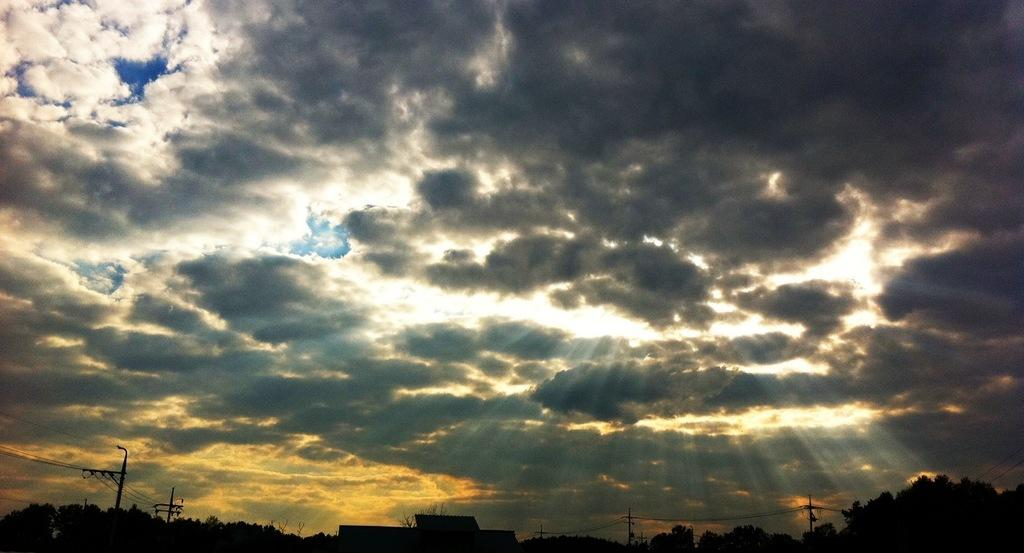What is connecting the poles in the image? Wires are connecting the poles in the image. What can be seen at the bottom of the image? There are trees and buildings at the bottom of the image. What is visible in the background of the image? The sky is visible in the background of the image. What can be observed in the sky? There are clouds in the sky. What type of vegetable is growing on the poles in the image? There are no vegetables growing on the poles in the image; they are connected with wires. Can you identify the actor who is standing near the trees in the image? There are no actors present in the image; it features poles, wires, trees, buildings, and the sky. 